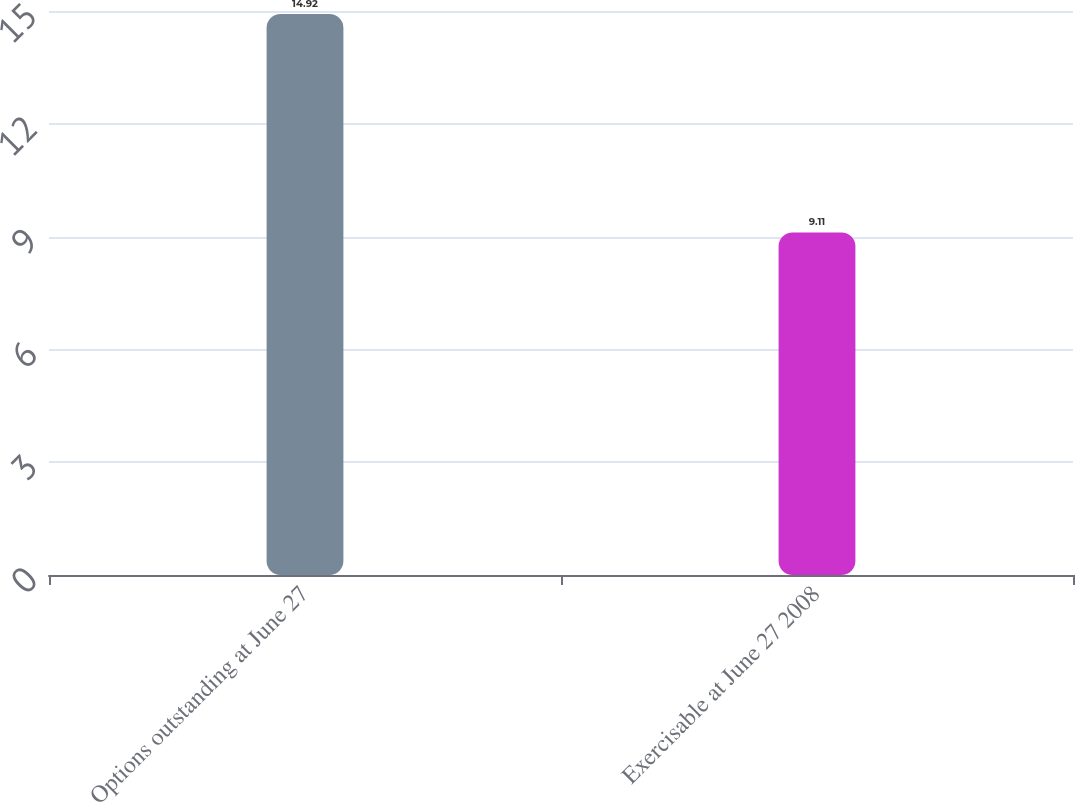<chart> <loc_0><loc_0><loc_500><loc_500><bar_chart><fcel>Options outstanding at June 27<fcel>Exercisable at June 27 2008<nl><fcel>14.92<fcel>9.11<nl></chart> 